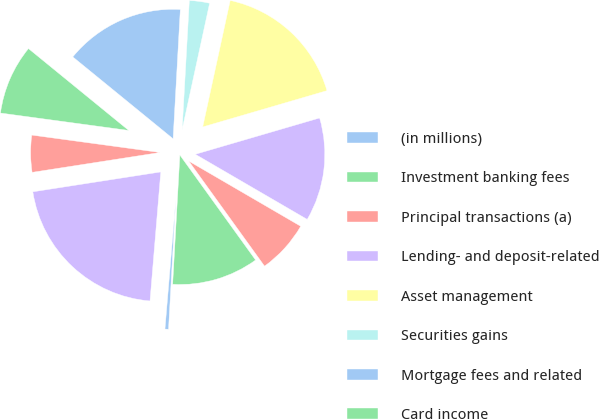Convert chart to OTSL. <chart><loc_0><loc_0><loc_500><loc_500><pie_chart><fcel>(in millions)<fcel>Investment banking fees<fcel>Principal transactions (a)<fcel>Lending- and deposit-related<fcel>Asset management<fcel>Securities gains<fcel>Mortgage fees and related<fcel>Card income<fcel>Other income (b)<fcel>Noninterest revenue<nl><fcel>0.44%<fcel>10.83%<fcel>6.67%<fcel>12.91%<fcel>17.07%<fcel>2.52%<fcel>14.99%<fcel>8.75%<fcel>4.6%<fcel>21.22%<nl></chart> 